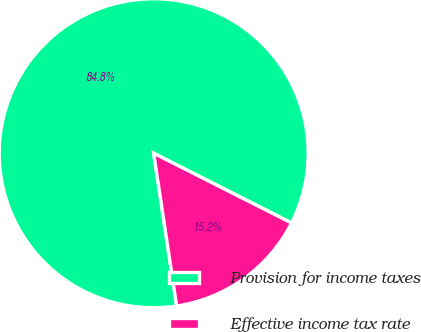<chart> <loc_0><loc_0><loc_500><loc_500><pie_chart><fcel>Provision for income taxes<fcel>Effective income tax rate<nl><fcel>84.83%<fcel>15.17%<nl></chart> 